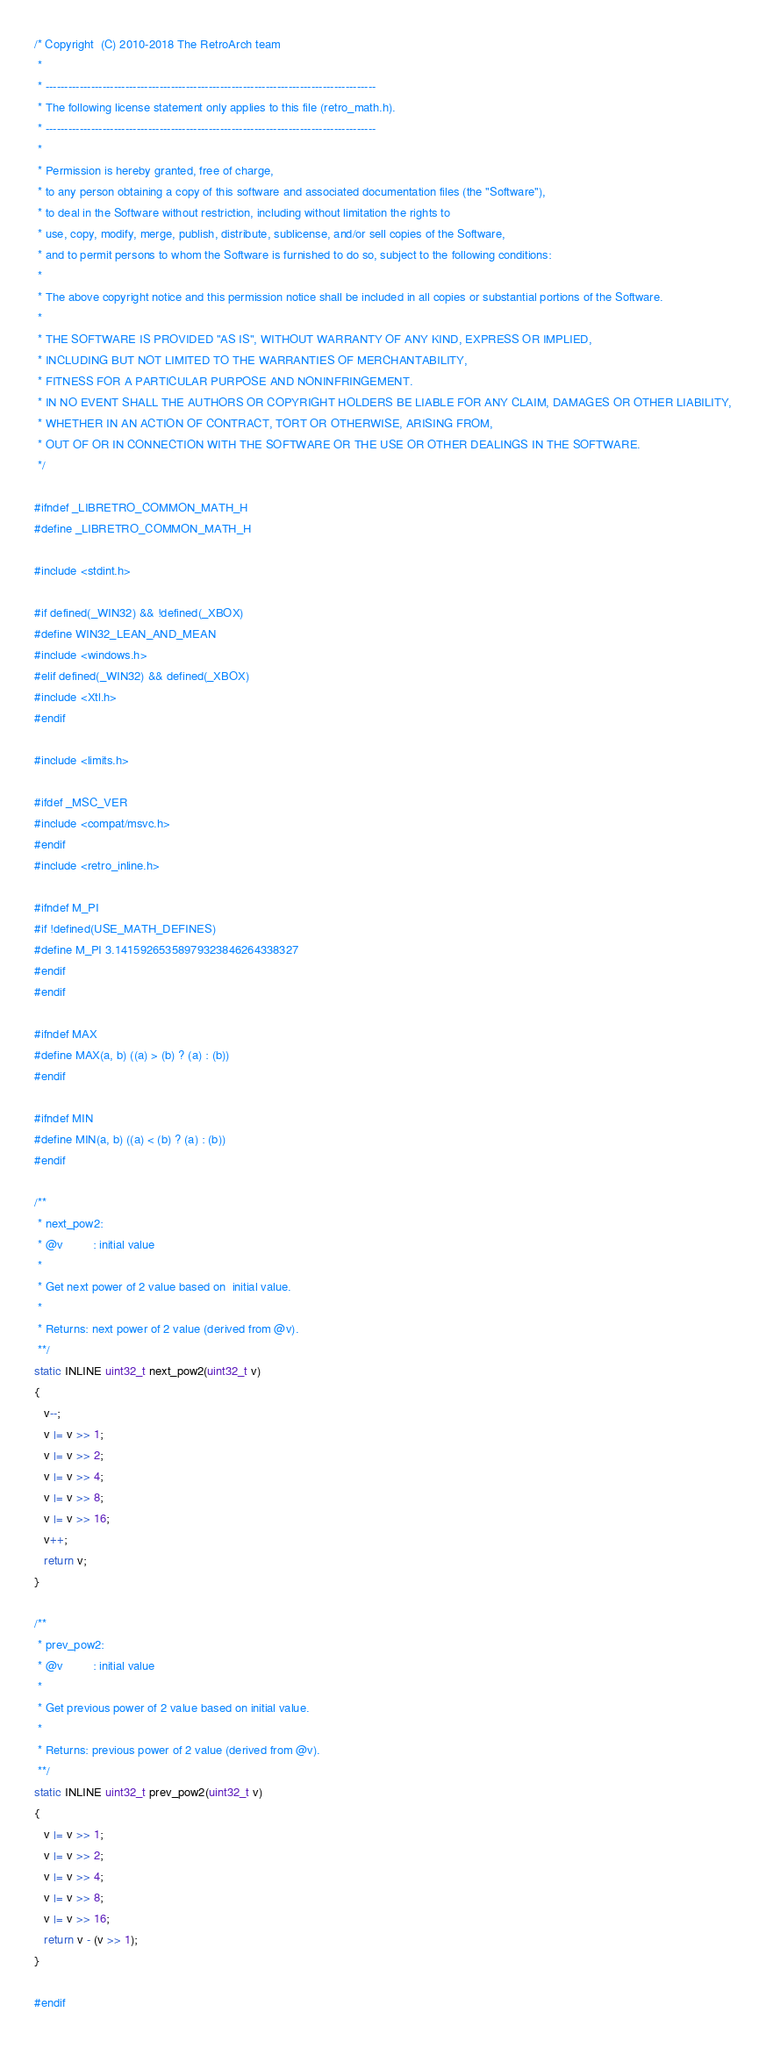<code> <loc_0><loc_0><loc_500><loc_500><_C_>/* Copyright  (C) 2010-2018 The RetroArch team
 *
 * ---------------------------------------------------------------------------------------
 * The following license statement only applies to this file (retro_math.h).
 * ---------------------------------------------------------------------------------------
 *
 * Permission is hereby granted, free of charge,
 * to any person obtaining a copy of this software and associated documentation files (the "Software"),
 * to deal in the Software without restriction, including without limitation the rights to
 * use, copy, modify, merge, publish, distribute, sublicense, and/or sell copies of the Software,
 * and to permit persons to whom the Software is furnished to do so, subject to the following conditions:
 *
 * The above copyright notice and this permission notice shall be included in all copies or substantial portions of the Software.
 *
 * THE SOFTWARE IS PROVIDED "AS IS", WITHOUT WARRANTY OF ANY KIND, EXPRESS OR IMPLIED,
 * INCLUDING BUT NOT LIMITED TO THE WARRANTIES OF MERCHANTABILITY,
 * FITNESS FOR A PARTICULAR PURPOSE AND NONINFRINGEMENT.
 * IN NO EVENT SHALL THE AUTHORS OR COPYRIGHT HOLDERS BE LIABLE FOR ANY CLAIM, DAMAGES OR OTHER LIABILITY,
 * WHETHER IN AN ACTION OF CONTRACT, TORT OR OTHERWISE, ARISING FROM,
 * OUT OF OR IN CONNECTION WITH THE SOFTWARE OR THE USE OR OTHER DEALINGS IN THE SOFTWARE.
 */

#ifndef _LIBRETRO_COMMON_MATH_H
#define _LIBRETRO_COMMON_MATH_H

#include <stdint.h>

#if defined(_WIN32) && !defined(_XBOX)
#define WIN32_LEAN_AND_MEAN
#include <windows.h>
#elif defined(_WIN32) && defined(_XBOX)
#include <Xtl.h>
#endif

#include <limits.h>

#ifdef _MSC_VER
#include <compat/msvc.h>
#endif
#include <retro_inline.h>

#ifndef M_PI
#if !defined(USE_MATH_DEFINES)
#define M_PI 3.14159265358979323846264338327
#endif
#endif

#ifndef MAX
#define MAX(a, b) ((a) > (b) ? (a) : (b))
#endif

#ifndef MIN
#define MIN(a, b) ((a) < (b) ? (a) : (b))
#endif

/**
 * next_pow2:
 * @v         : initial value
 *
 * Get next power of 2 value based on  initial value.
 *
 * Returns: next power of 2 value (derived from @v).
 **/
static INLINE uint32_t next_pow2(uint32_t v)
{
   v--;
   v |= v >> 1;
   v |= v >> 2;
   v |= v >> 4;
   v |= v >> 8;
   v |= v >> 16;
   v++;
   return v;
}

/**
 * prev_pow2:
 * @v         : initial value
 *
 * Get previous power of 2 value based on initial value.
 *
 * Returns: previous power of 2 value (derived from @v).
 **/
static INLINE uint32_t prev_pow2(uint32_t v)
{
   v |= v >> 1;
   v |= v >> 2;
   v |= v >> 4;
   v |= v >> 8;
   v |= v >> 16;
   return v - (v >> 1);
}

#endif
</code> 